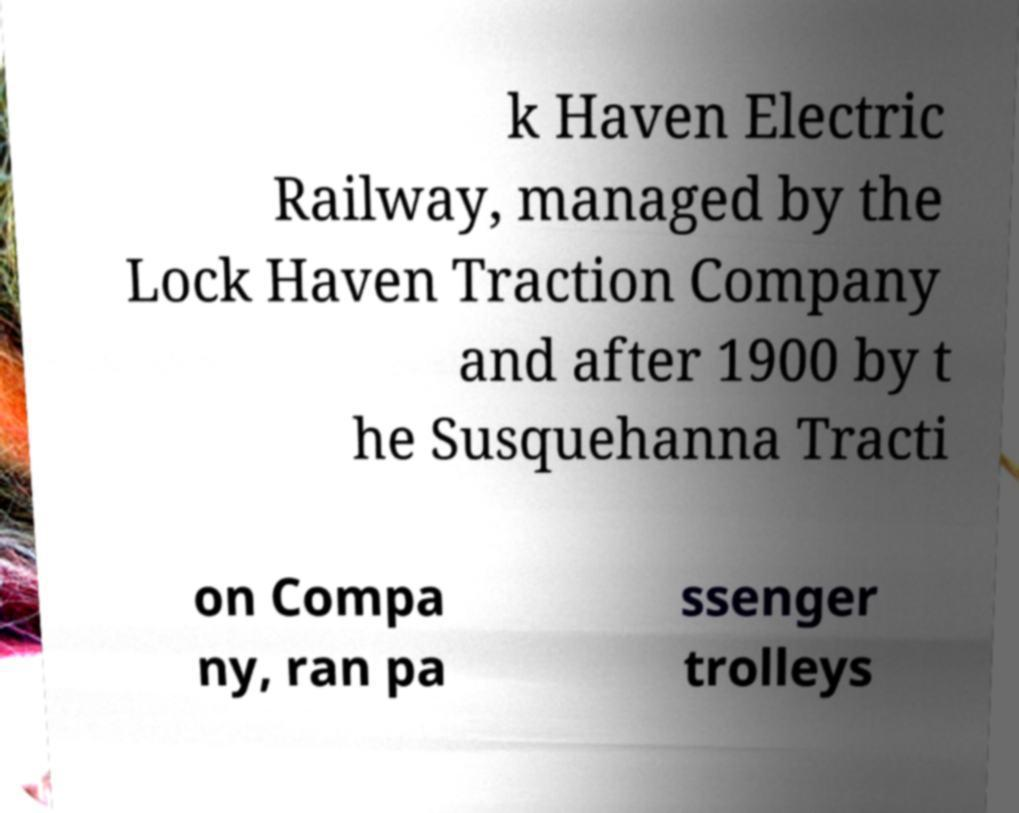Please identify and transcribe the text found in this image. k Haven Electric Railway, managed by the Lock Haven Traction Company and after 1900 by t he Susquehanna Tracti on Compa ny, ran pa ssenger trolleys 